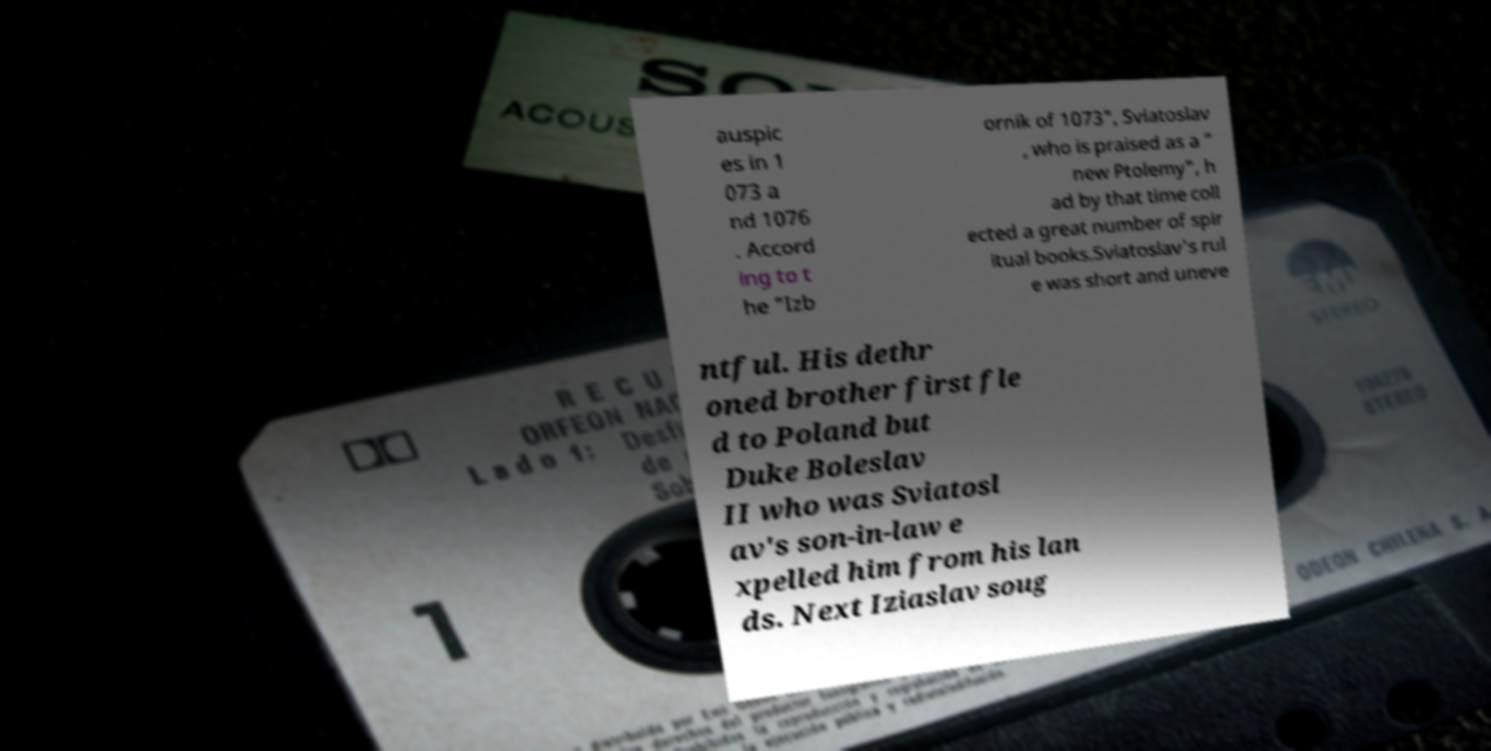Can you accurately transcribe the text from the provided image for me? auspic es in 1 073 a nd 1076 . Accord ing to t he "Izb ornik of 1073", Sviatoslav , who is praised as a " new Ptolemy", h ad by that time coll ected a great number of spir itual books.Sviatoslav's rul e was short and uneve ntful. His dethr oned brother first fle d to Poland but Duke Boleslav II who was Sviatosl av's son-in-law e xpelled him from his lan ds. Next Iziaslav soug 